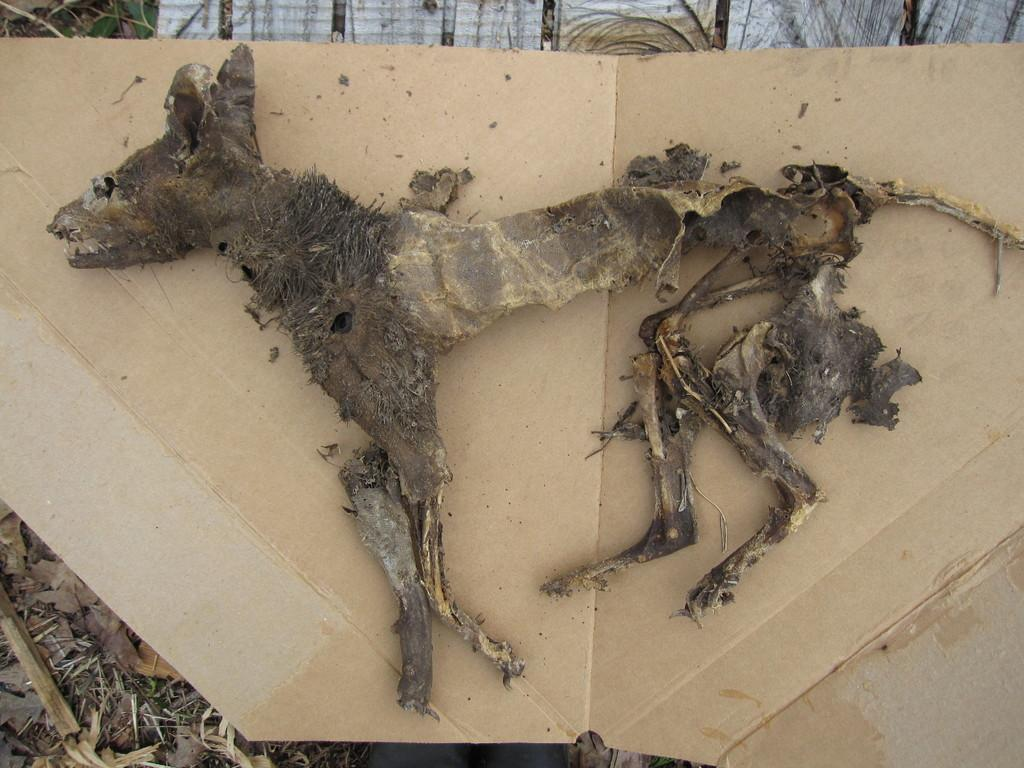What is the main subject of the image? There is an animal skeleton in the image. What is the surface that the skeleton is placed on? The surface the skeleton is on resembles cardboard. What type of natural elements can be seen on the ground in the image? There are dry leaves on the ground in the image. What other unspecified items are present on the ground in the image? There are other unspecified items on the ground in the image. How does the animal skeleton transport itself in the image? The animal skeleton does not transport itself in the image; it is stationary on the cardboard surface. What type of shock can be seen affecting the animal skeleton in the image? There is no shock affecting the animal skeleton in the image; it is simply a skeleton placed on a surface. 